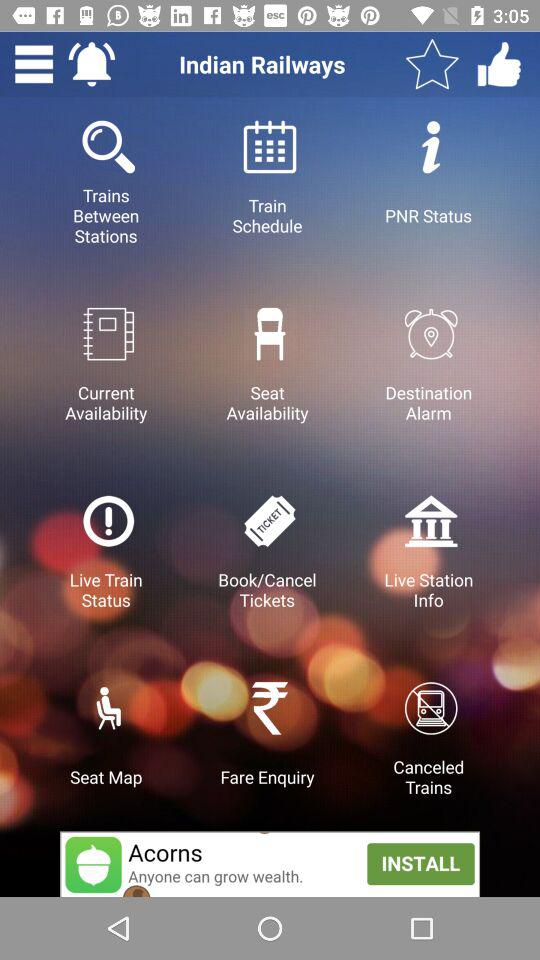What is the application name? The application name is "Indian Railways". 